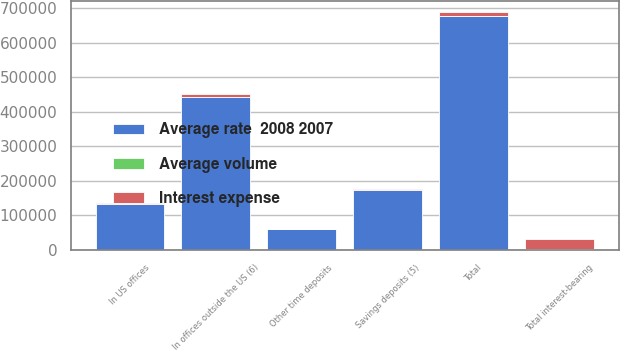Convert chart. <chart><loc_0><loc_0><loc_500><loc_500><stacked_bar_chart><ecel><fcel>Savings deposits (5)<fcel>Other time deposits<fcel>In offices outside the US (6)<fcel>Total<fcel>In US offices<fcel>Total interest-bearing<nl><fcel>Average rate  2008 2007<fcel>174260<fcel>59673<fcel>443601<fcel>677534<fcel>133375<fcel>2765<nl><fcel>Interest expense<fcel>2765<fcel>1104<fcel>6277<fcel>10146<fcel>988<fcel>27721<nl><fcel>Average volume<fcel>1.59<fcel>1.85<fcel>1.42<fcel>1.5<fcel>0.74<fcel>1.92<nl></chart> 